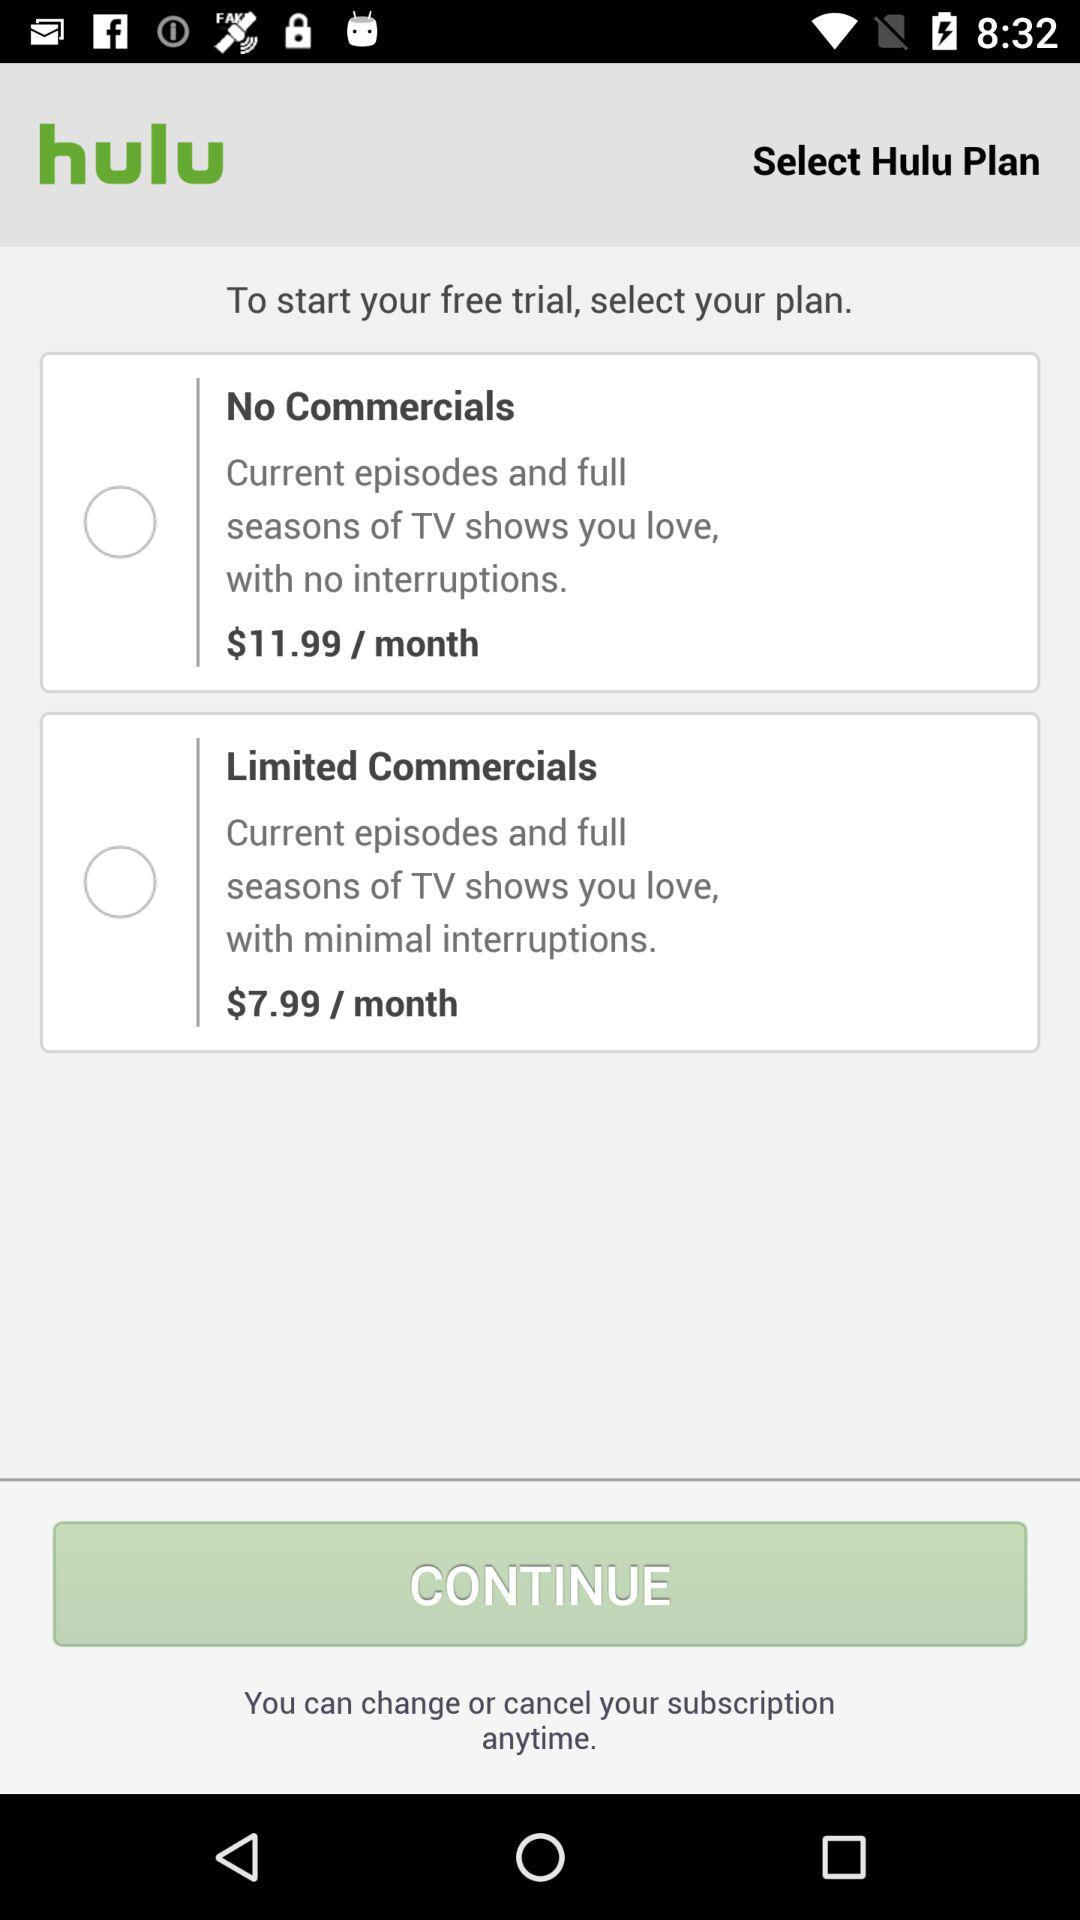What is the price per month for "No Commercials"? The price per month is $11.99. 